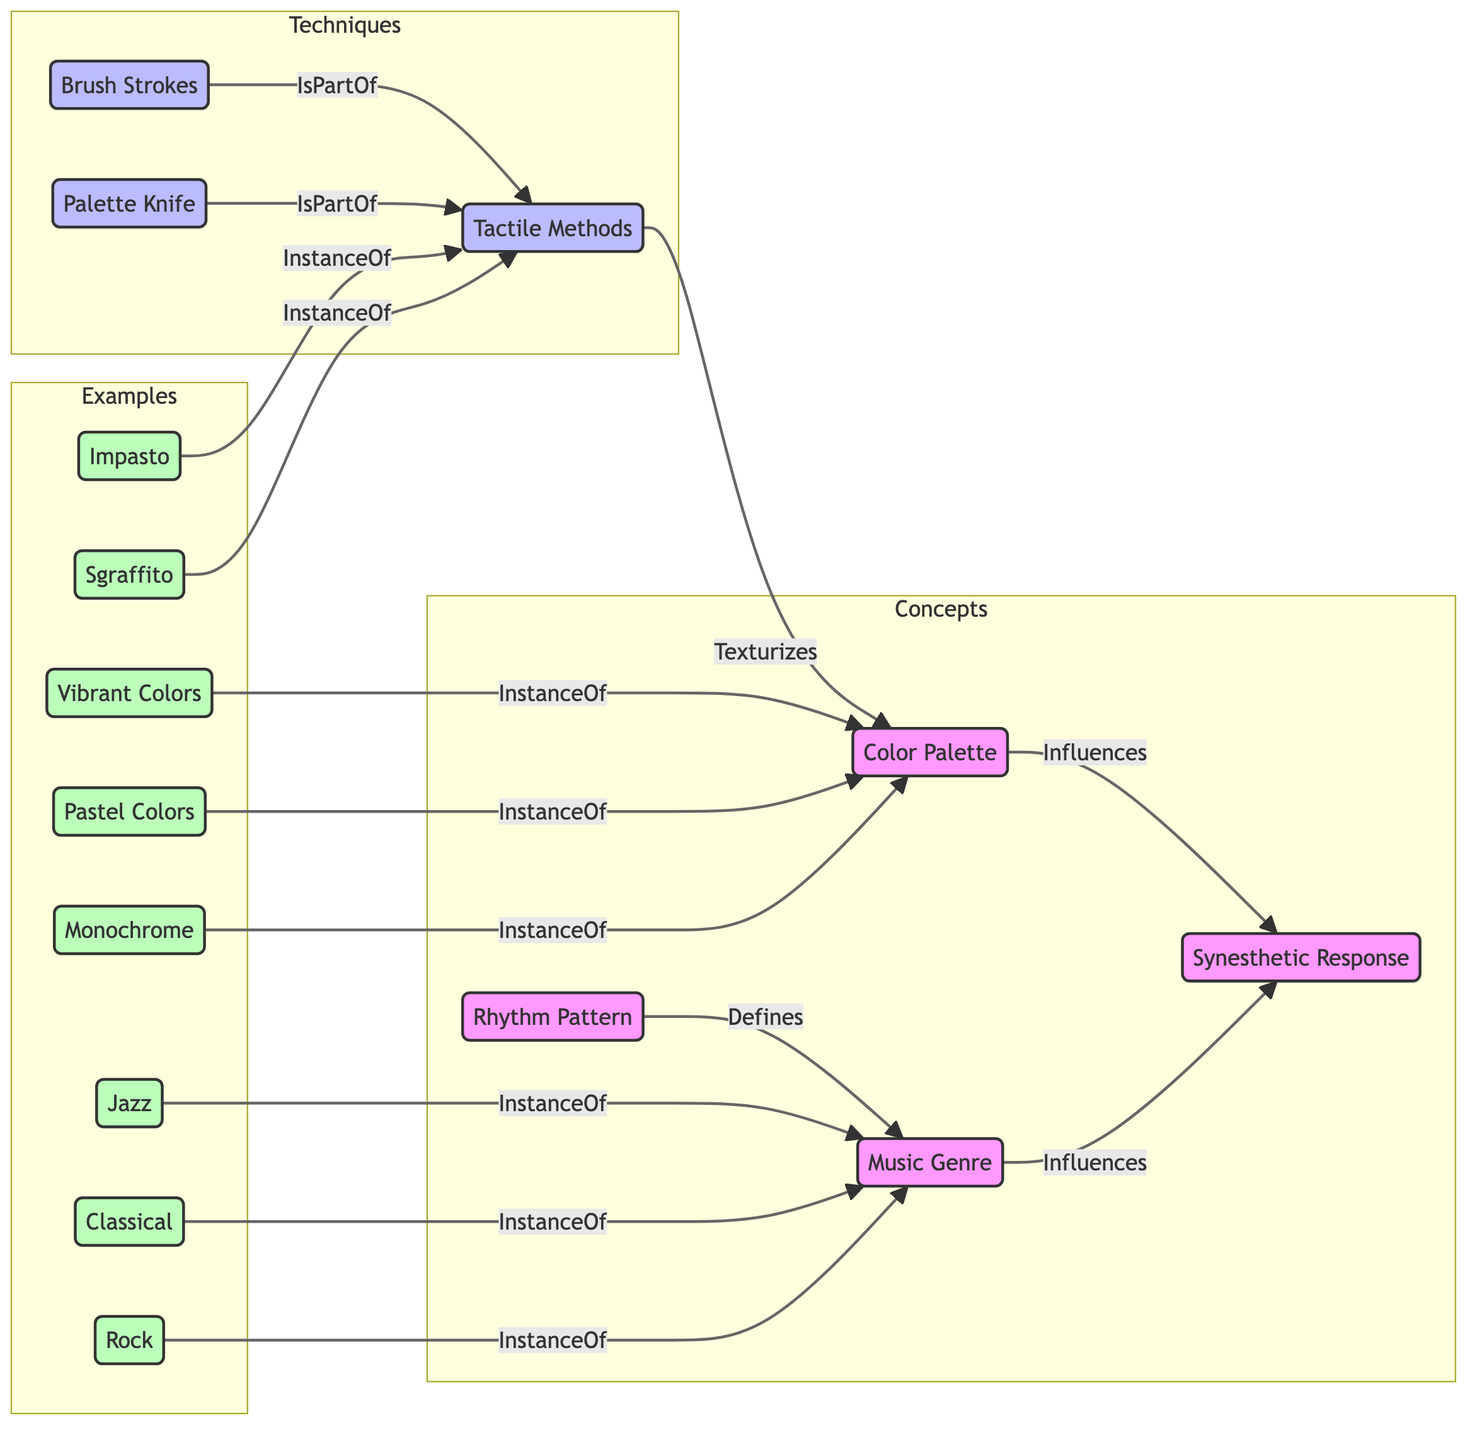What is the total number of nodes in the diagram? Count the nodes listed: Color Palette, Synesthetic Response, Music Genre, Rhythm Pattern, Tactile Methods, Brush Strokes, Palette Knife, Jazz, Classical, Rock, Vibrant Colors, Pastel Colors, Monochrome, Impasto, and Sgraffito. This totals to 14 nodes.
Answer: 14 Which technique is a part of Tactile Methods? The diagram indicates that Brush Strokes and Palette Knife are both linked to Tactile Methods as parts. Thus, both are techniques under Tactile Methods. A single answer as a specific technique is "Brush Strokes".
Answer: Brush Strokes What color choice influences the Synesthetic Response? The link from Color Palette to Synesthetic Response shows the influence relationship. This means the Color Palette impacts how one experiences synesthetic responses. Choosing a color would give us this answer. A specific answer is "Vibrant Colors" as one instance under the Color Palette.
Answer: Vibrant Colors How does Rhythm Pattern relate to Music Genre? The arrow from Rhythm Pattern to Music Genre labeled "Defines" shows the relationship. This signifies that the rhythm pattern gives characteristics to the music genre, hence it defines the genre in broader terms.
Answer: Defines Which genre directly influences the Synesthetic Response? Looking at the links to Synesthetic Response, both Music Genre and Color Palette influence it. However, if we look for specific genres, Jazz, Classical, and Rock directly signify the styles that show influence. We can say "Jazz" as a single instance in answering this.
Answer: Jazz What are the examples of color palettes in the diagram? Multiple links lead to Color Palette, listing Vibrant Colors, Pastel Colors, and Monochrome. To answer, combine these instances and emphasize that they are examples of color choices from the diagram.
Answer: Vibrant Colors, Pastel Colors, Monochrome Which rhythmic pattern category defines Jazz? The diagram infers that Rhythm Pattern categorizes music genres, including Jazz, Classical, and Rock. Jazz does not point explicitly to a ‘rhythm pattern’ but is part of the example flow through Music Genre. Hence it must relate as it resembles something in the category.
Answer: Defines How many instances are there under Music Genre? Jaz, Classical, and Rock are all instances linked to Music Genre. Counting these gives us a total of three distinct entries for music genres.
Answer: 3 What forms of Tactile Methods are present in the diagram? The nodes linked to Tactile Methods specify examples like Impasto and Sgraffito. These define the tactile methods and therefore answer by listing these.
Answer: Impasto, Sgraffito 